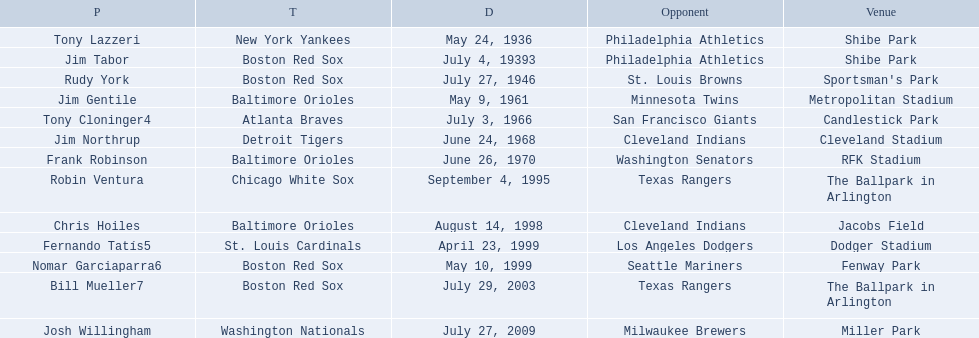Who are the opponents of the boston red sox during baseball home run records? Philadelphia Athletics, St. Louis Browns, Seattle Mariners, Texas Rangers. Of those which was the opponent on july 27, 1946? St. Louis Browns. 